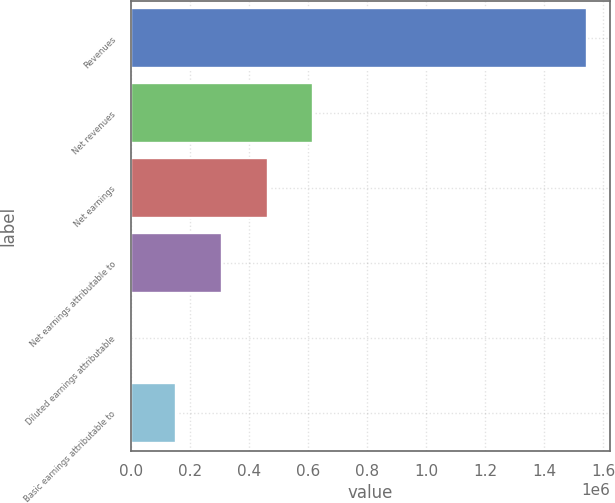Convert chart. <chart><loc_0><loc_0><loc_500><loc_500><bar_chart><fcel>Revenues<fcel>Net revenues<fcel>Net earnings<fcel>Net earnings attributable to<fcel>Diluted earnings attributable<fcel>Basic earnings attributable to<nl><fcel>1.54513e+06<fcel>618053<fcel>463540<fcel>309027<fcel>0.51<fcel>154514<nl></chart> 